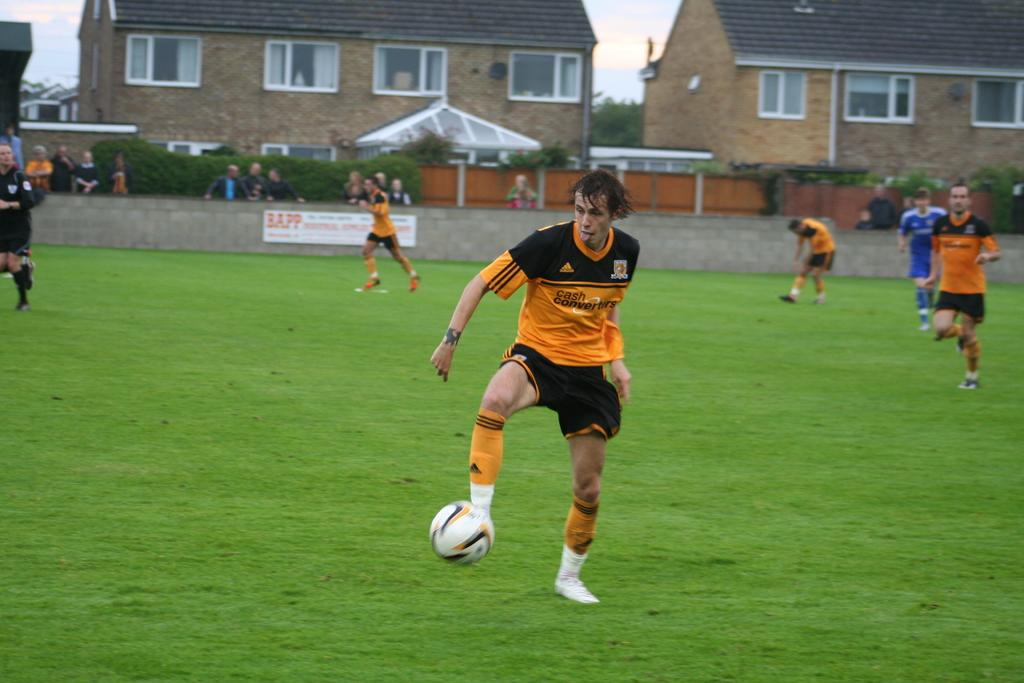What sport are the players engaged in within the image? The players are playing football in the image. What is the color of the football field? The football field is green. What can be seen in the background of the image? There are houses visible in the image. What type of vegetation is present in the image? There are plants in the image. Are there any spectators present in the image? Yes, there are people standing and watching the football game. What type of texture does the turkey have in the image? There is no turkey present in the image, so it is not possible to determine its texture. 